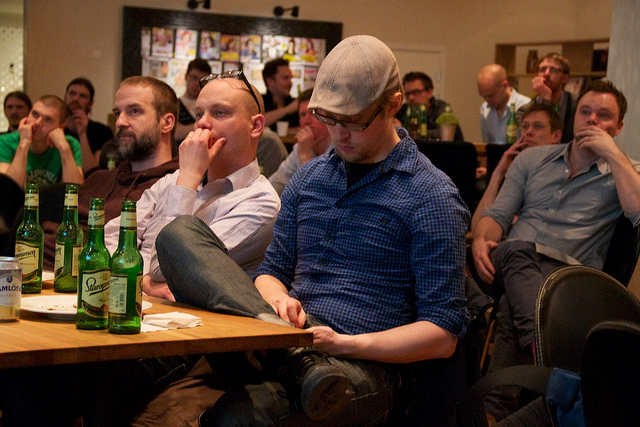<image>What brand of soda is being drunk? I am unsure what brand of soda is being drunk. It could be sprite or beer. What brand of soda is being drunk? It is ambiguous what brand of soda is being drunk. It can be seen 'sprite', 'beer' or 'none'. 